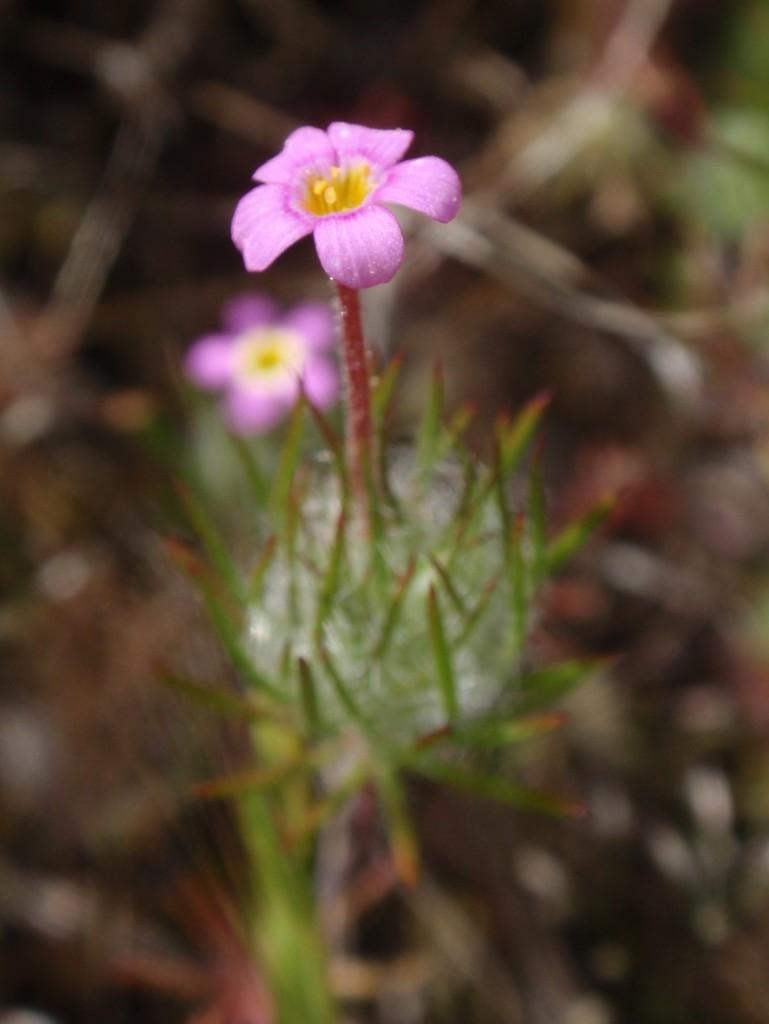What type of living organisms can be seen in the image? There are flowers in the image. Can you describe the background of the image? The background of the image is blurred. What type of birds can be seen starting a unit in the image? There are no birds or units present in the image; it features flowers and a blurred background. 